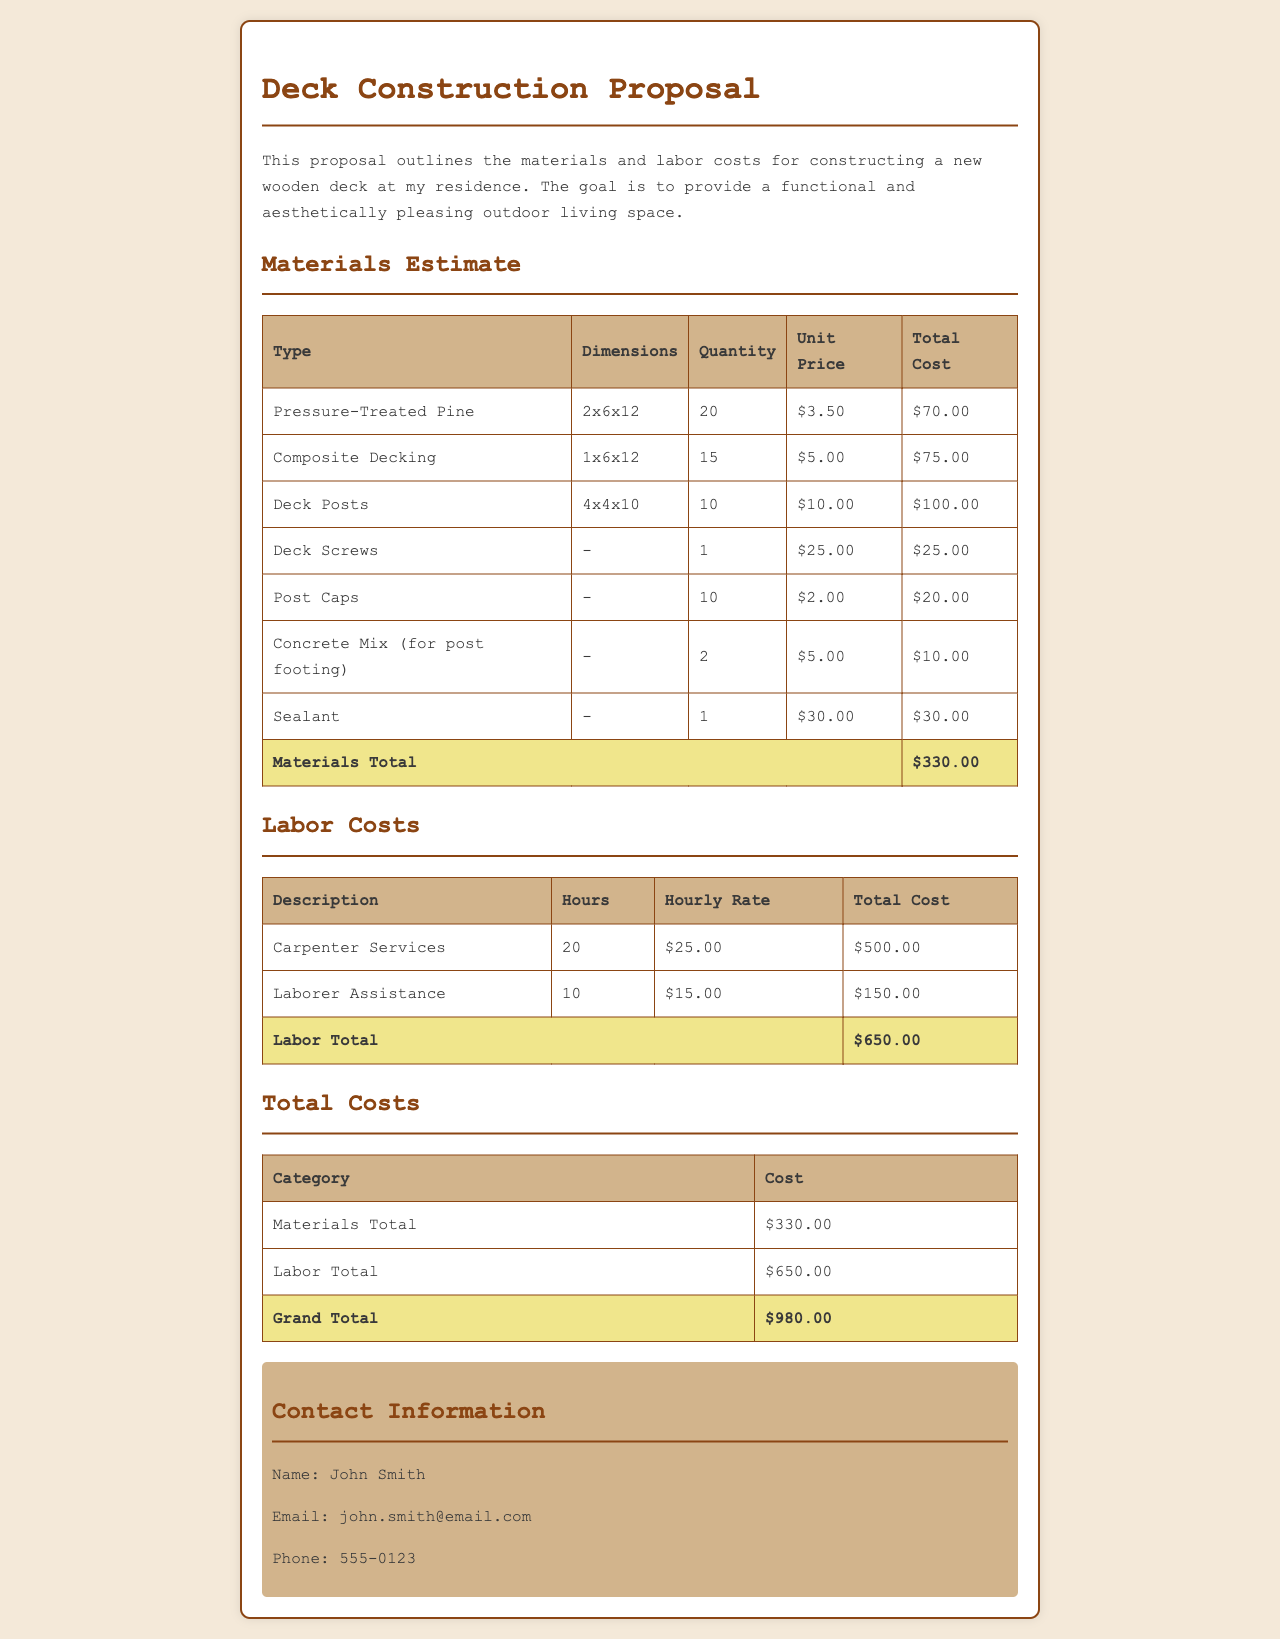What is the total cost of materials? The total cost of materials is located in the Materials Estimate section of the document.
Answer: $330.00 How many deck posts are estimated in the proposal? The quantity of deck posts is listed under the Materials Estimate table.
Answer: 10 What is the hourly rate for carpenter services? The hourly rate for carpenter services is provided in the Labor Costs section of the document.
Answer: $25.00 What is the total labor cost? The total cost of labor is found in the Labor Costs table.
Answer: $650.00 Who is the contact person for this proposal? The proposal includes contact information in the Contact Information section.
Answer: John Smith What is the grand total cost for the project? The grand total cost is summarized at the end of the Total Costs table.
Answer: $980.00 How many hours are estimated for laborer assistance? The hours for laborer assistance are found in the Labor Costs section.
Answer: 10 What type of decking is listed in the materials? The type of decking is specified in the Materials Estimate section, under the first row of the table.
Answer: Composite Decking What is the quantity of concrete mix needed for post footing? The quantity of concrete mix is mentioned in the Materials Estimate table.
Answer: 2 